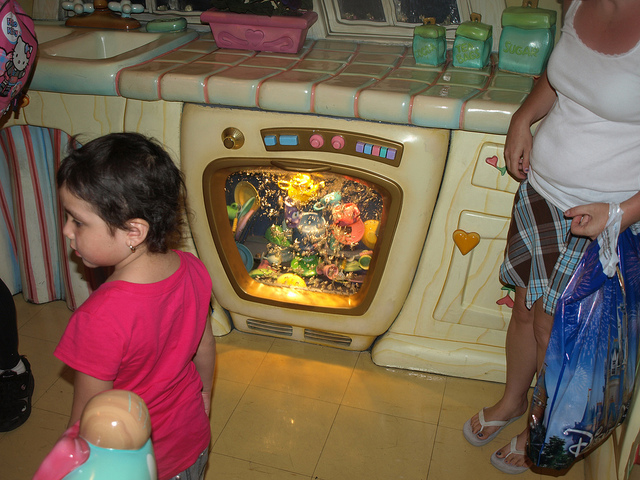What is the child looking at? The child seems to be looking at a colorful aquarium scene displayed inside what appears to be an oven. 